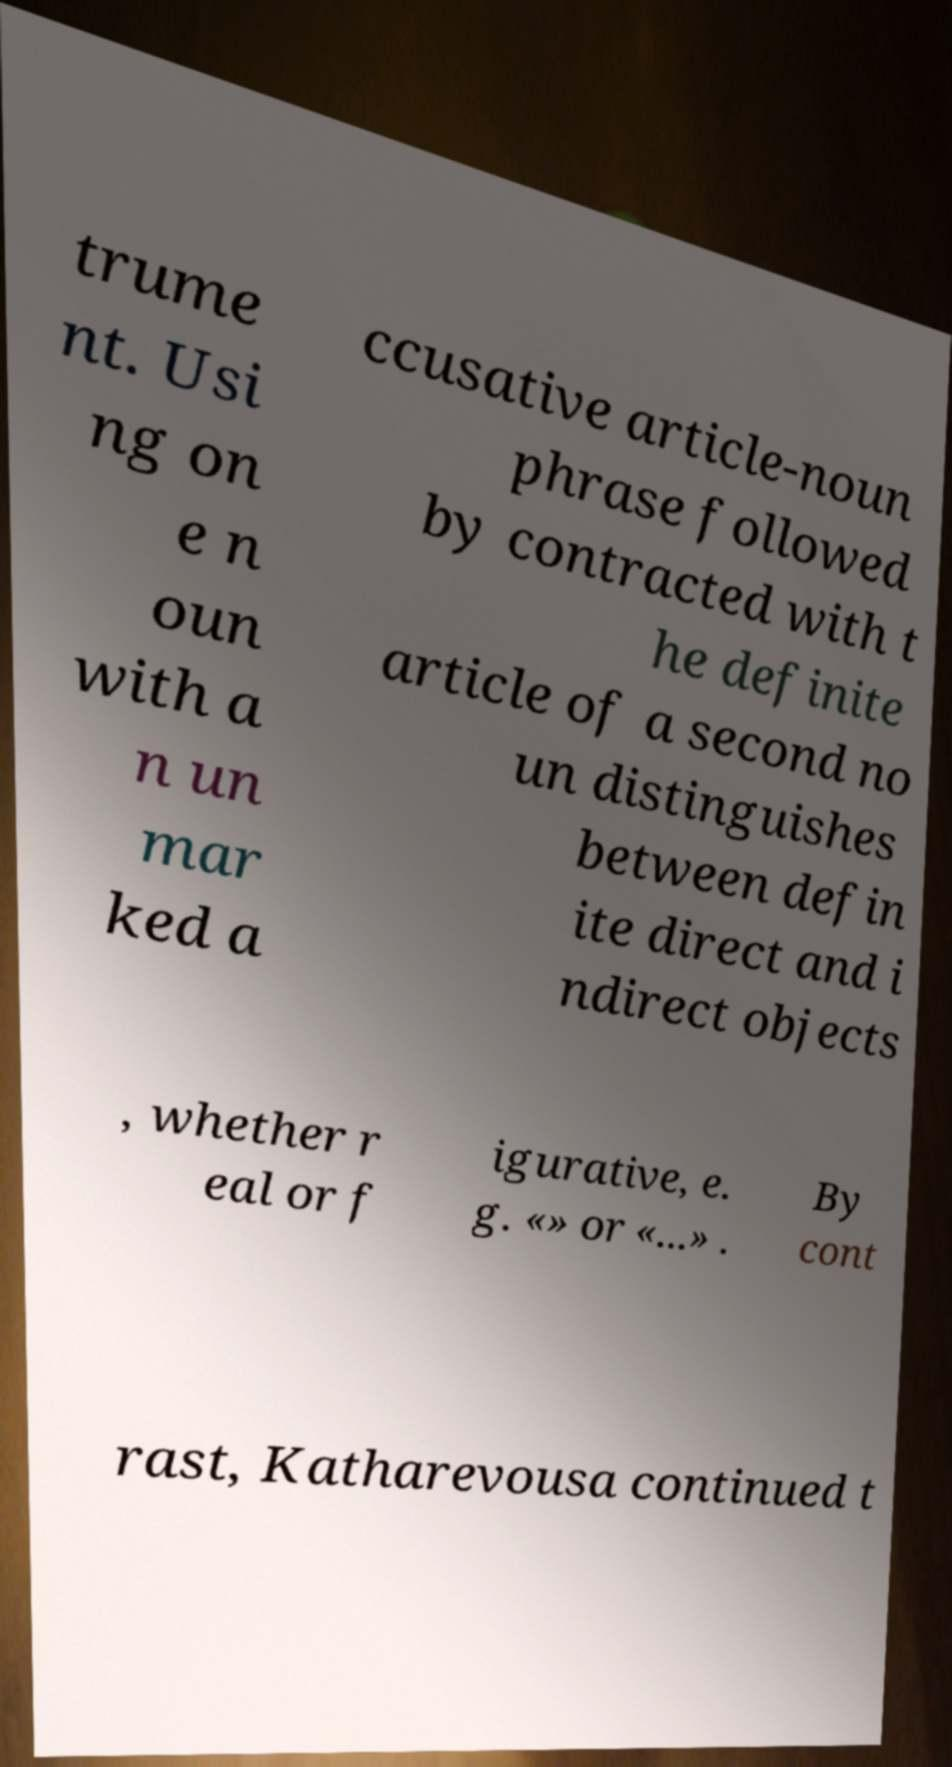Please identify and transcribe the text found in this image. trume nt. Usi ng on e n oun with a n un mar ked a ccusative article-noun phrase followed by contracted with t he definite article of a second no un distinguishes between defin ite direct and i ndirect objects , whether r eal or f igurative, e. g. «» or «...» . By cont rast, Katharevousa continued t 